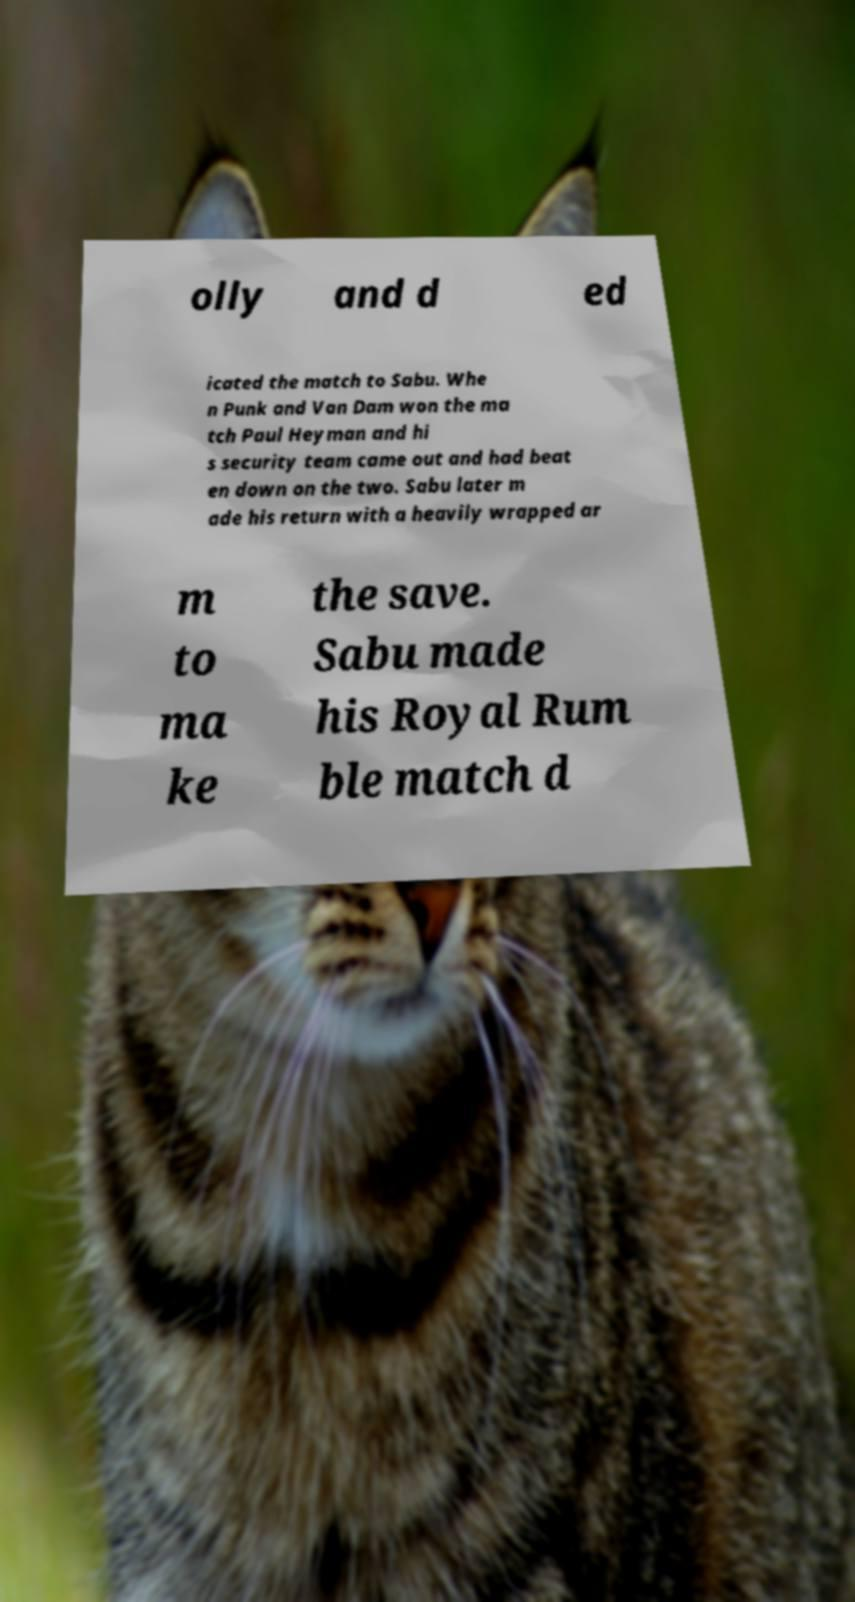Please read and relay the text visible in this image. What does it say? olly and d ed icated the match to Sabu. Whe n Punk and Van Dam won the ma tch Paul Heyman and hi s security team came out and had beat en down on the two. Sabu later m ade his return with a heavily wrapped ar m to ma ke the save. Sabu made his Royal Rum ble match d 